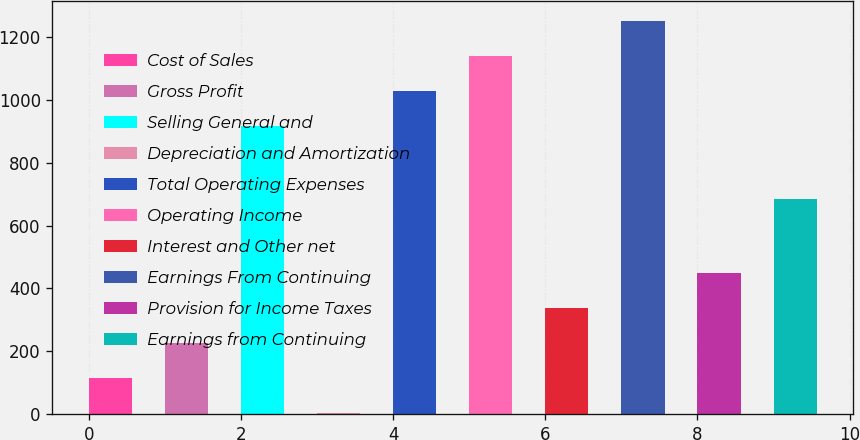Convert chart. <chart><loc_0><loc_0><loc_500><loc_500><bar_chart><fcel>Cost of Sales<fcel>Gross Profit<fcel>Selling General and<fcel>Depreciation and Amortization<fcel>Total Operating Expenses<fcel>Operating Income<fcel>Interest and Other net<fcel>Earnings From Continuing<fcel>Provision for Income Taxes<fcel>Earnings from Continuing<nl><fcel>114.1<fcel>225.2<fcel>918<fcel>3<fcel>1029.1<fcel>1140.2<fcel>336.3<fcel>1251.3<fcel>447.4<fcel>684<nl></chart> 